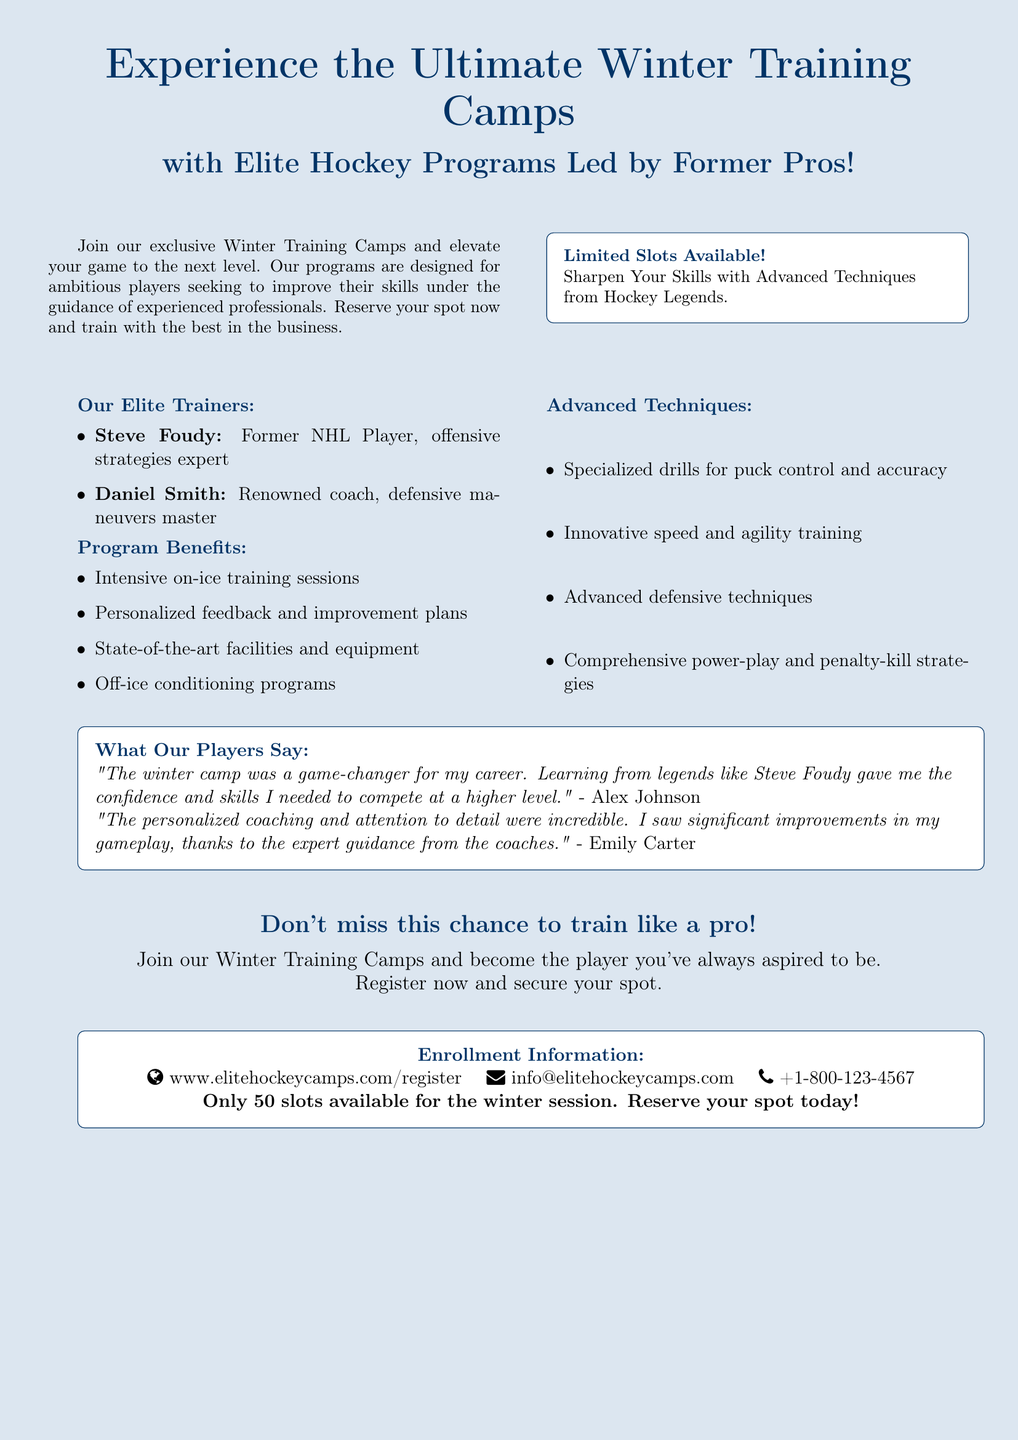What are the names of the elite trainers? The document provides the names of the elite trainers leading the program, which are Steve Foudy and Daniel Smith.
Answer: Steve Foudy, Daniel Smith What is the maximum number of slots available for enrollment? The document specifies that only 50 slots are available for the winter session.
Answer: 50 What techniques can players expect to learn? The advertisement lists advanced techniques such as puck control, speed and agility training, and power-play strategies.
Answer: Specialized drills for puck control, speed and agility training What is one benefit of the program mentioned in the document? The document outlines several benefits including intensive on-ice training sessions and personalized feedback.
Answer: Intensive on-ice training sessions Who provided feedback in the document about the winter training camp? The document features testimonials from players including Alex Johnson and Emily Carter.
Answer: Alex Johnson, Emily Carter What is the primary audience for the winter training camps? The advertisement targets ambitious players looking to improve their skills in ice hockey.
Answer: Ambitious players What is the focus area of Steve Foudy's expertise? The document specifically mentions that Steve Foudy is an expert in offensive strategies.
Answer: Offensive strategies 